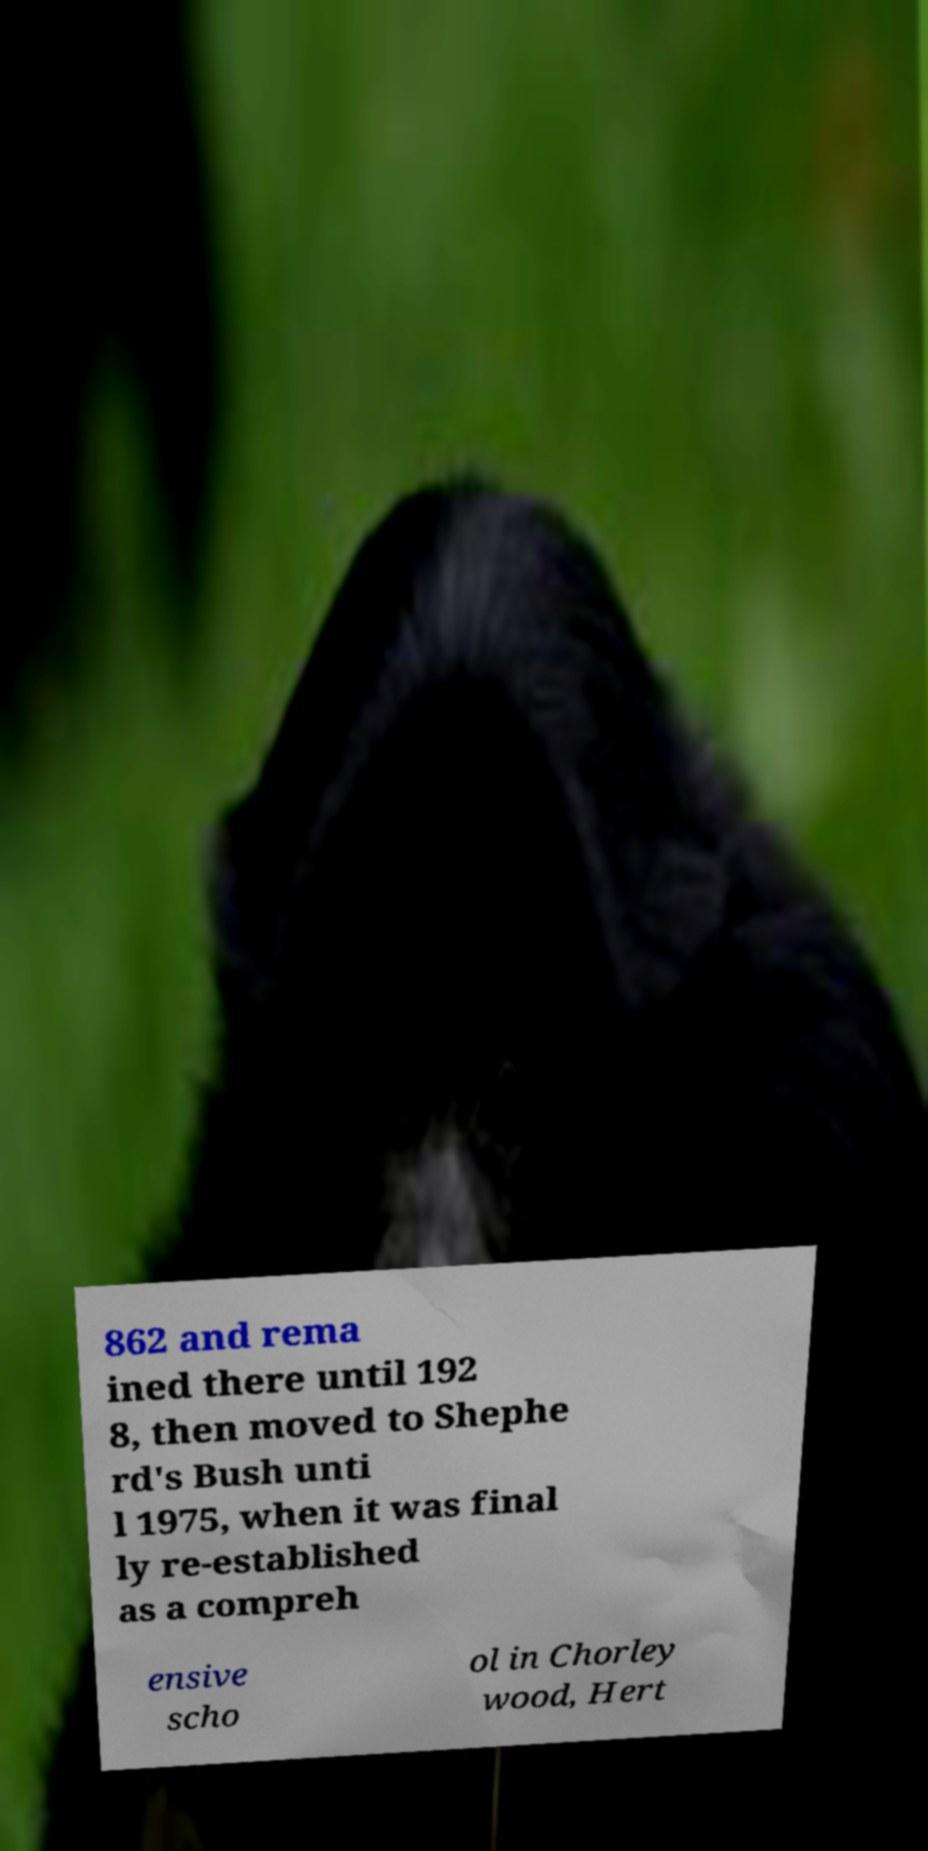Can you accurately transcribe the text from the provided image for me? 862 and rema ined there until 192 8, then moved to Shephe rd's Bush unti l 1975, when it was final ly re-established as a compreh ensive scho ol in Chorley wood, Hert 